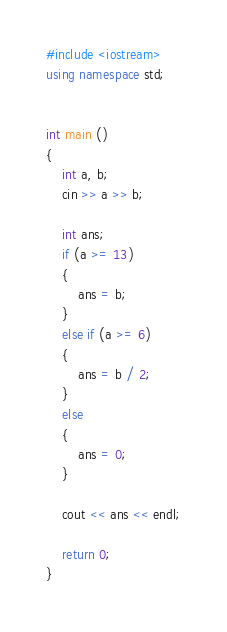<code> <loc_0><loc_0><loc_500><loc_500><_C++_>#include <iostream>
using namespace std;


int main ()
{
    int a, b;
    cin >> a >> b;

    int ans;
    if (a >= 13)
    {
        ans = b;
    }
    else if (a >= 6)
    {
        ans = b / 2;
    }
    else
    {
        ans = 0;
    }

    cout << ans << endl;

    return 0;
}</code> 